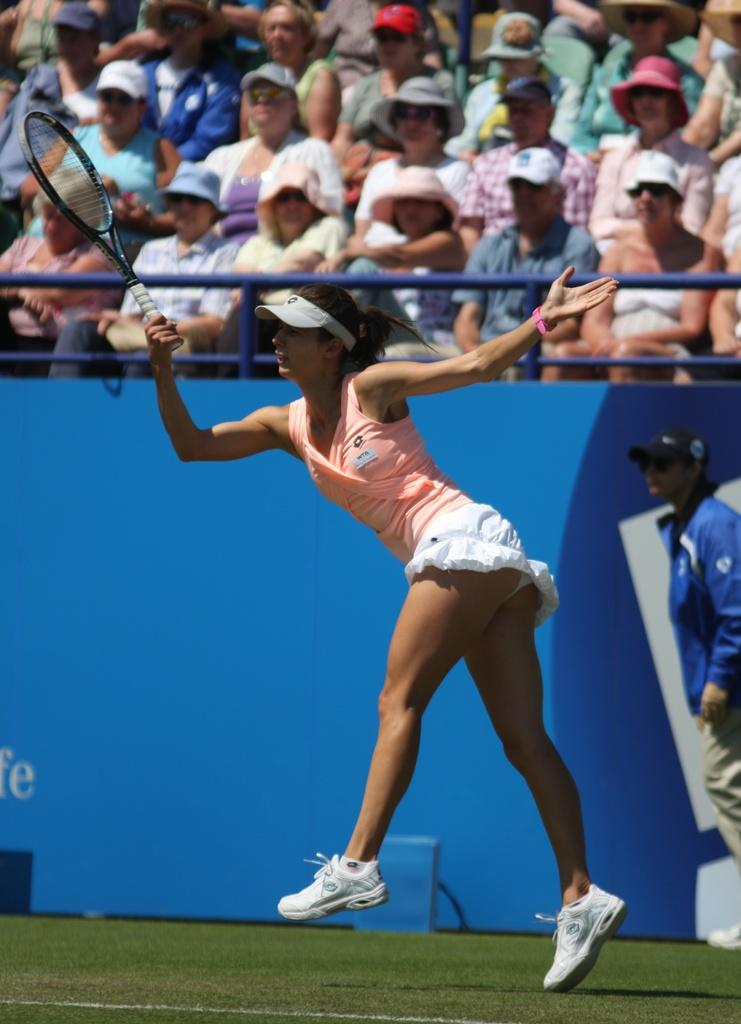How many people are present in the image? There are two people on the ground in the image. What is one of the people holding? One woman is holding a tennis racket. What can be seen in the background of the image? There is a fence and a group of people in the background of the image. What type of tools does the carpenter have in the image? There is no carpenter present in the image, nor are there any tools visible. What is inside the jar that is visible in the image? There is no jar present in the image. 